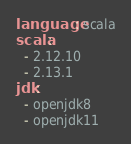Convert code to text. <code><loc_0><loc_0><loc_500><loc_500><_YAML_>language: scala
scala:
  - 2.12.10
  - 2.13.1
jdk:
  - openjdk8
  - openjdk11
</code> 